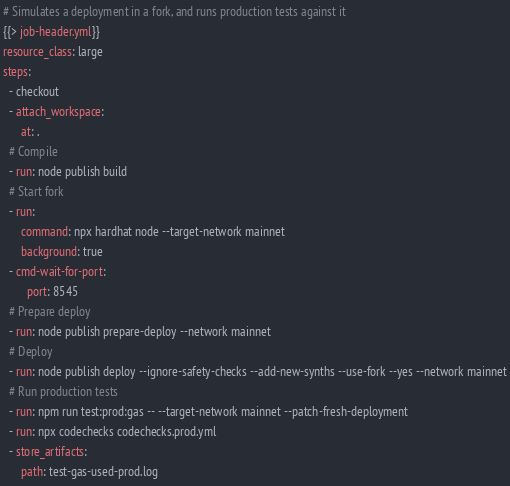<code> <loc_0><loc_0><loc_500><loc_500><_YAML_># Simulates a deployment in a fork, and runs production tests against it
{{> job-header.yml}}
resource_class: large
steps:
  - checkout
  - attach_workspace:
      at: .
  # Compile
  - run: node publish build
  # Start fork
  - run:
      command: npx hardhat node --target-network mainnet
      background: true
  - cmd-wait-for-port:
        port: 8545
  # Prepare deploy
  - run: node publish prepare-deploy --network mainnet
  # Deploy
  - run: node publish deploy --ignore-safety-checks --add-new-synths --use-fork --yes --network mainnet
  # Run production tests
  - run: npm run test:prod:gas -- --target-network mainnet --patch-fresh-deployment
  - run: npx codechecks codechecks.prod.yml
  - store_artifacts:
      path: test-gas-used-prod.log
</code> 